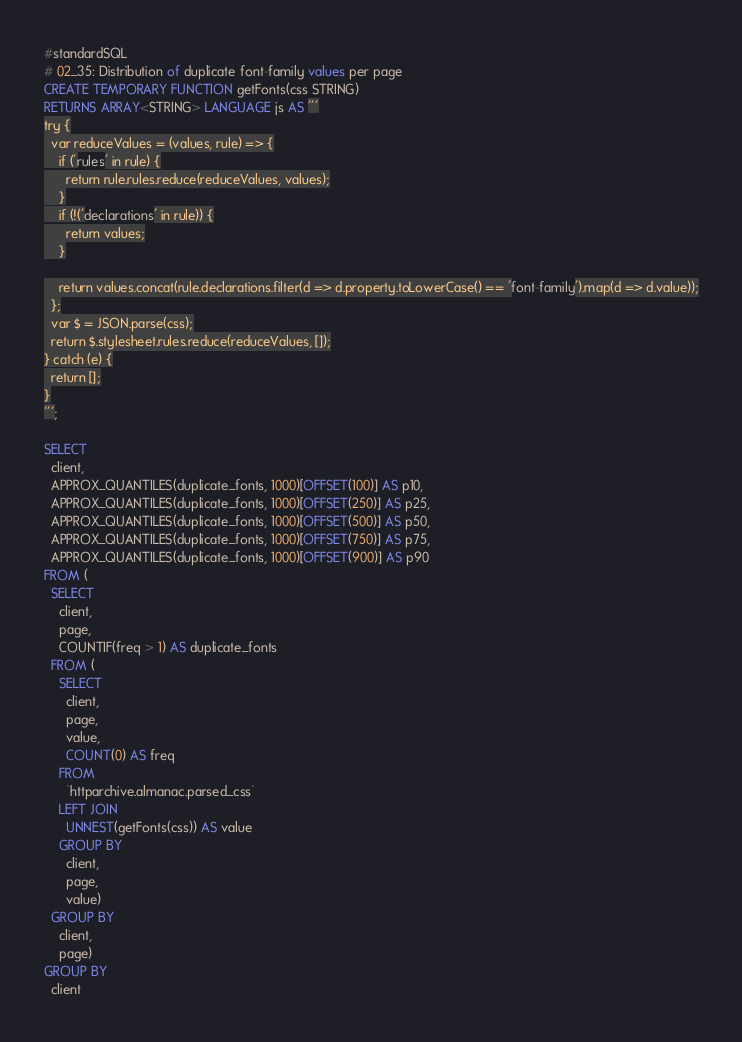Convert code to text. <code><loc_0><loc_0><loc_500><loc_500><_SQL_>#standardSQL
# 02_35: Distribution of duplicate font-family values per page
CREATE TEMPORARY FUNCTION getFonts(css STRING)
RETURNS ARRAY<STRING> LANGUAGE js AS '''
try {
  var reduceValues = (values, rule) => {
    if ('rules' in rule) {
      return rule.rules.reduce(reduceValues, values);
    }
    if (!('declarations' in rule)) {
      return values;
    }

    return values.concat(rule.declarations.filter(d => d.property.toLowerCase() == 'font-family').map(d => d.value));
  };
  var $ = JSON.parse(css);
  return $.stylesheet.rules.reduce(reduceValues, []);
} catch (e) {
  return [];
}
''';

SELECT
  client,
  APPROX_QUANTILES(duplicate_fonts, 1000)[OFFSET(100)] AS p10,
  APPROX_QUANTILES(duplicate_fonts, 1000)[OFFSET(250)] AS p25,
  APPROX_QUANTILES(duplicate_fonts, 1000)[OFFSET(500)] AS p50,
  APPROX_QUANTILES(duplicate_fonts, 1000)[OFFSET(750)] AS p75,
  APPROX_QUANTILES(duplicate_fonts, 1000)[OFFSET(900)] AS p90
FROM (
  SELECT
    client,
    page,
    COUNTIF(freq > 1) AS duplicate_fonts
  FROM (
    SELECT
      client,
      page,
      value,
      COUNT(0) AS freq
    FROM
      `httparchive.almanac.parsed_css`
    LEFT JOIN
      UNNEST(getFonts(css)) AS value
    GROUP BY
      client,
      page,
      value)
  GROUP BY
    client,
    page)
GROUP BY
  client</code> 